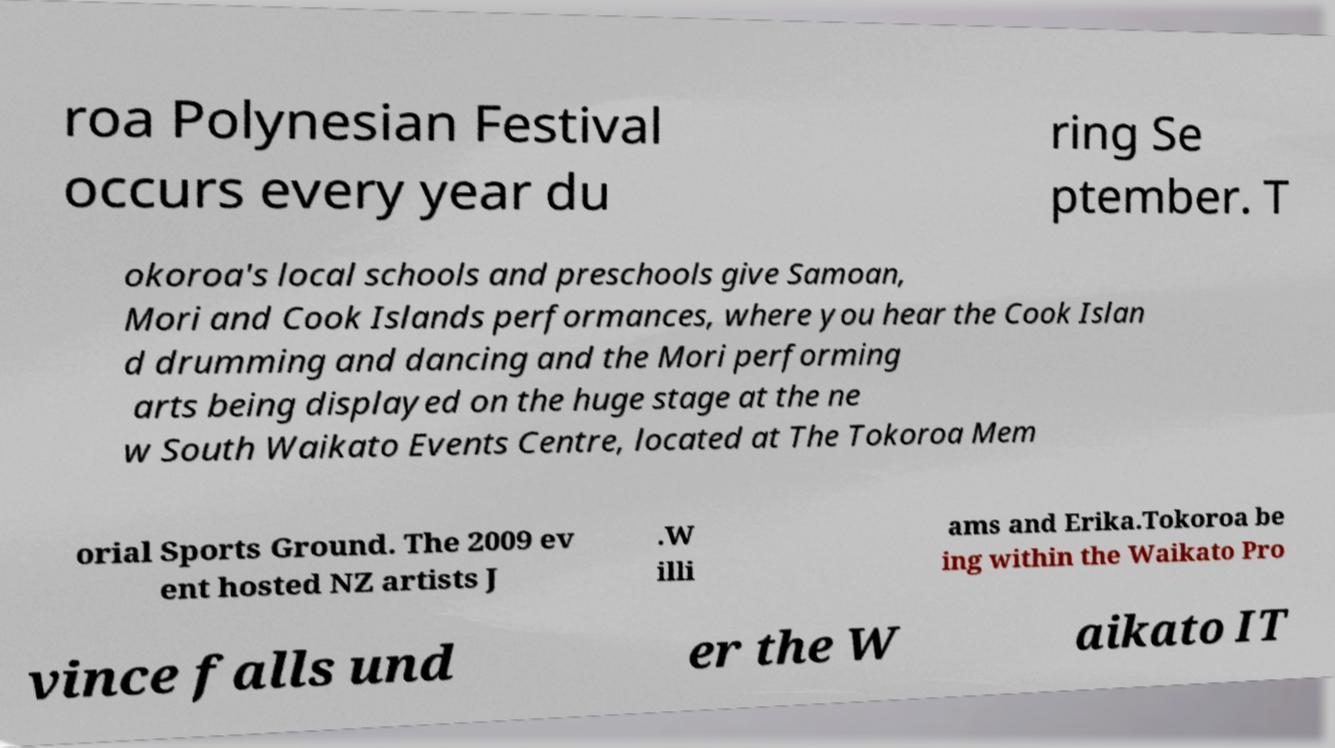Could you extract and type out the text from this image? roa Polynesian Festival occurs every year du ring Se ptember. T okoroa's local schools and preschools give Samoan, Mori and Cook Islands performances, where you hear the Cook Islan d drumming and dancing and the Mori performing arts being displayed on the huge stage at the ne w South Waikato Events Centre, located at The Tokoroa Mem orial Sports Ground. The 2009 ev ent hosted NZ artists J .W illi ams and Erika.Tokoroa be ing within the Waikato Pro vince falls und er the W aikato IT 